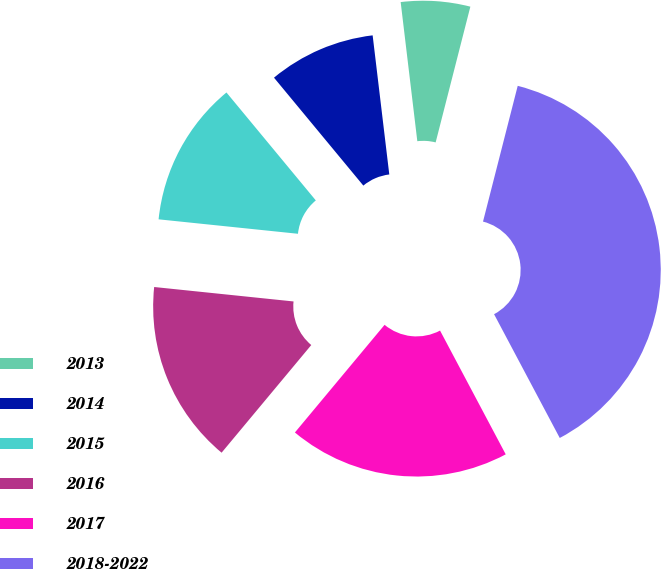Convert chart. <chart><loc_0><loc_0><loc_500><loc_500><pie_chart><fcel>2013<fcel>2014<fcel>2015<fcel>2016<fcel>2017<fcel>2018-2022<nl><fcel>5.88%<fcel>9.11%<fcel>12.35%<fcel>15.59%<fcel>18.82%<fcel>38.25%<nl></chart> 